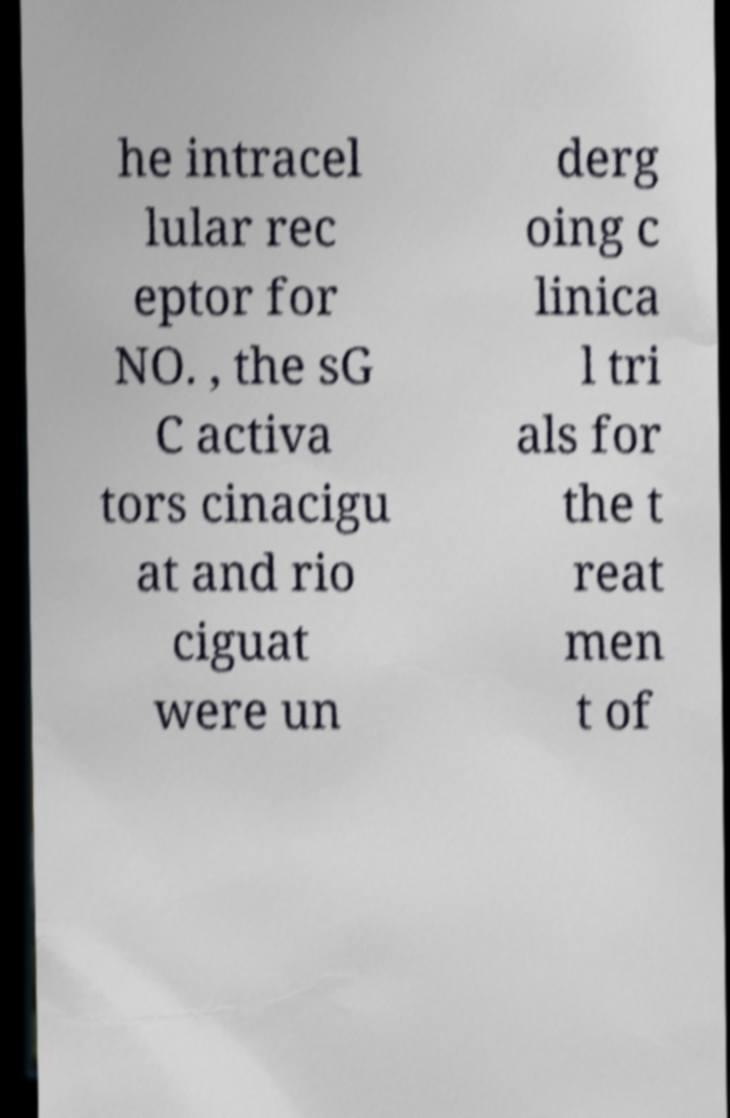Please read and relay the text visible in this image. What does it say? he intracel lular rec eptor for NO. , the sG C activa tors cinacigu at and rio ciguat were un derg oing c linica l tri als for the t reat men t of 